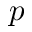Convert formula to latex. <formula><loc_0><loc_0><loc_500><loc_500>p</formula> 